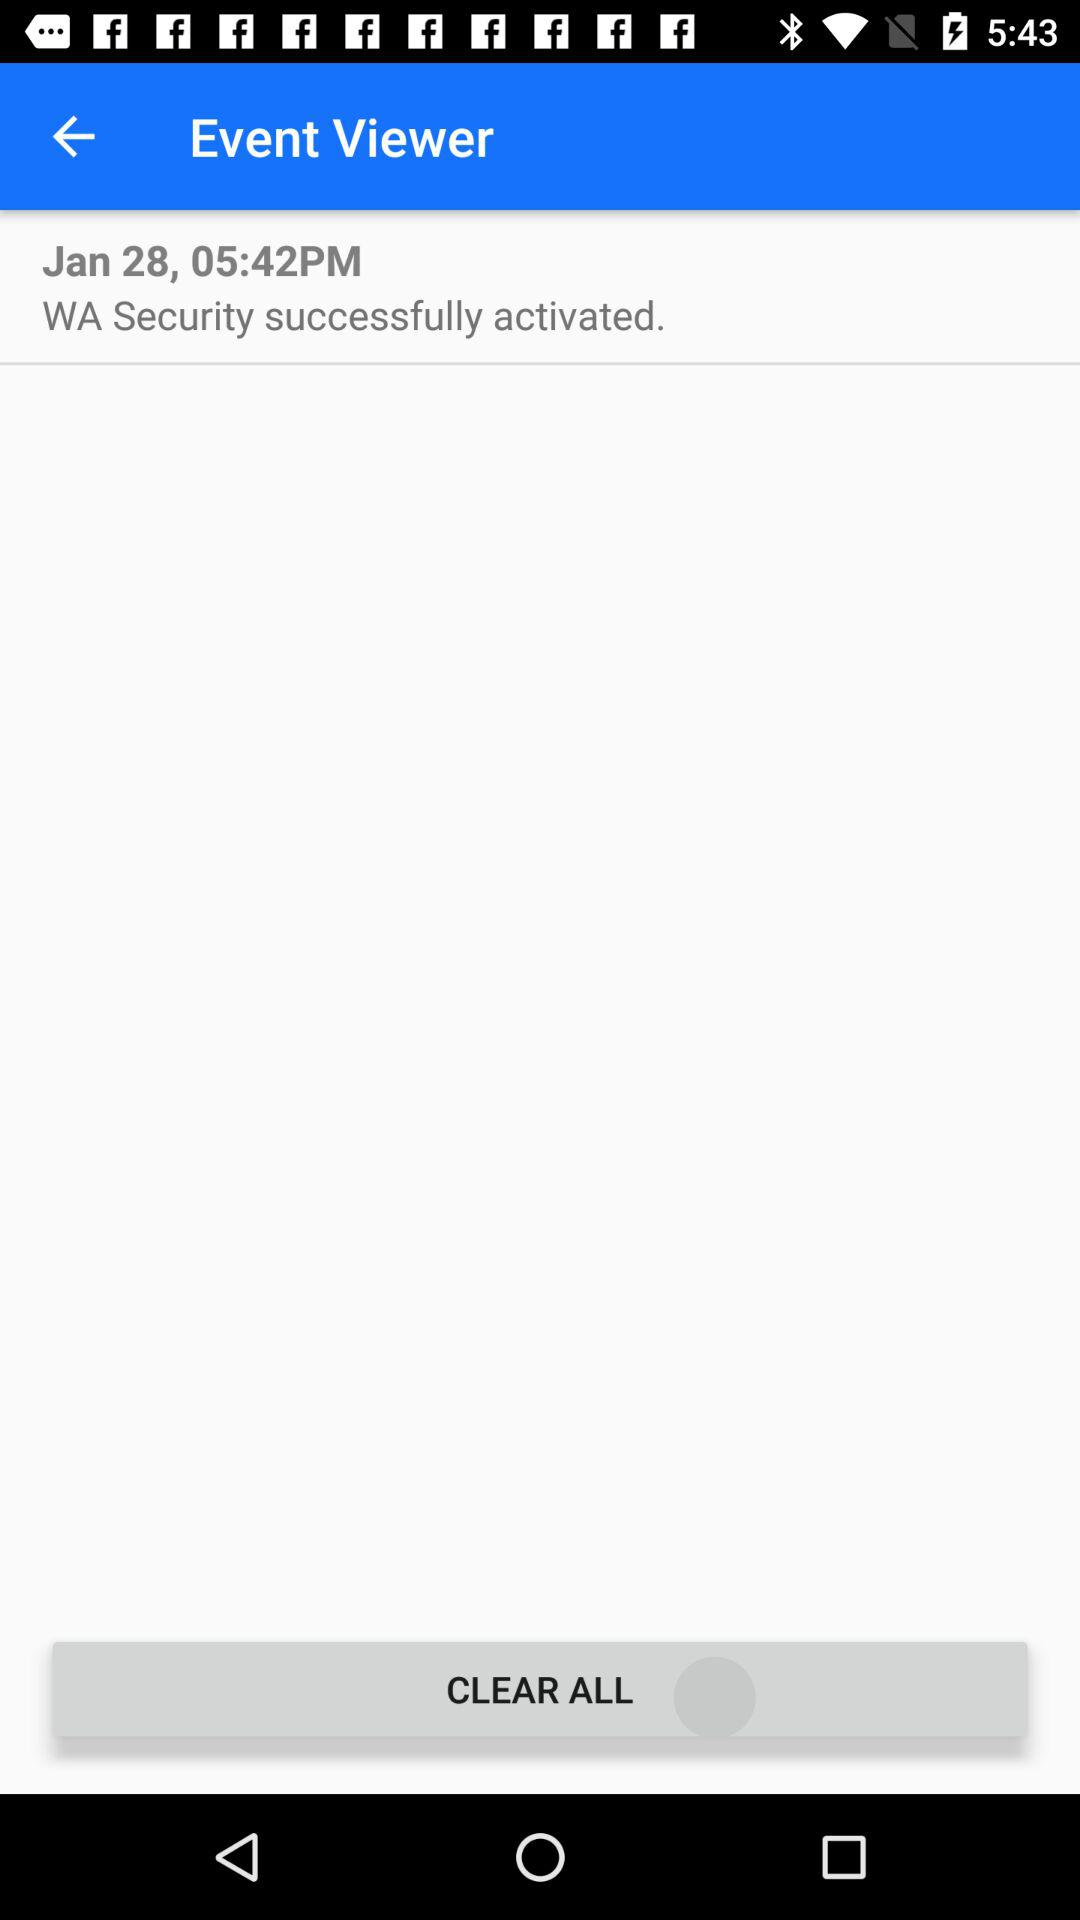What security has been successfully activated? The security that has been successfully activated is WA. 